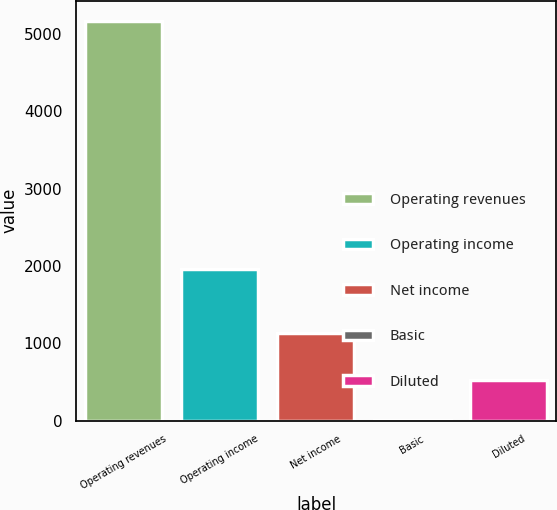Convert chart to OTSL. <chart><loc_0><loc_0><loc_500><loc_500><bar_chart><fcel>Operating revenues<fcel>Operating income<fcel>Net income<fcel>Basic<fcel>Diluted<nl><fcel>5174<fcel>1960<fcel>1131<fcel>1.36<fcel>518.62<nl></chart> 